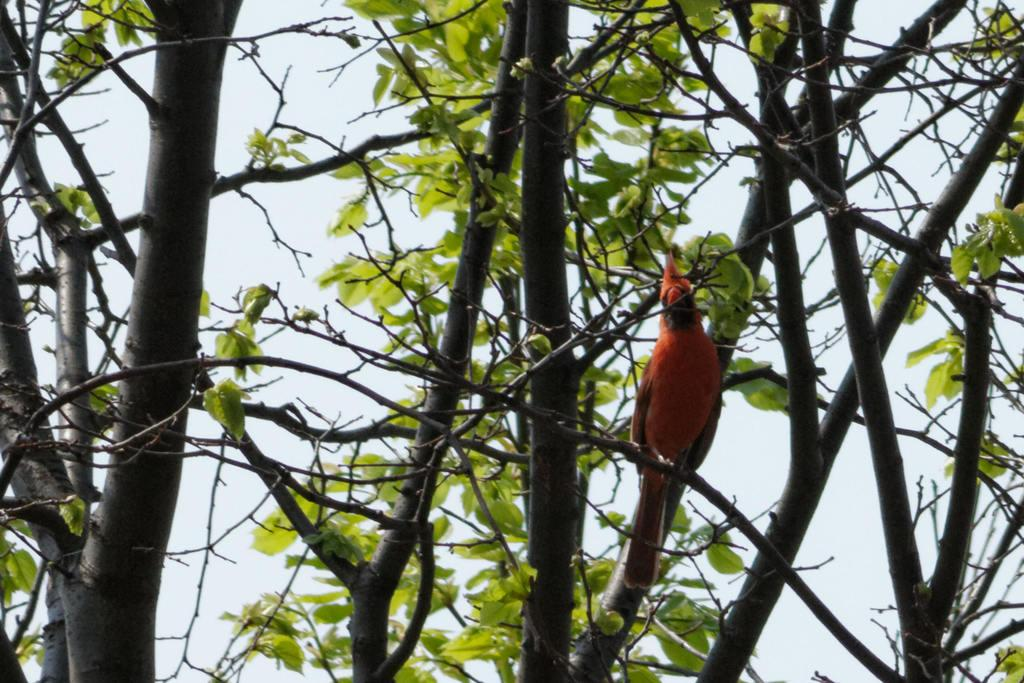What type of bird is in the image? There is an orange colored parrot in the image. Where is the parrot located? The parrot is on the branches of a tree. What can be seen in the background of the image? The sky is visible in the background of the image. What type of discussion is the parrot having with the pig in the image? There is no pig present in the image, so there cannot be a discussion between the parrot and a pig. 